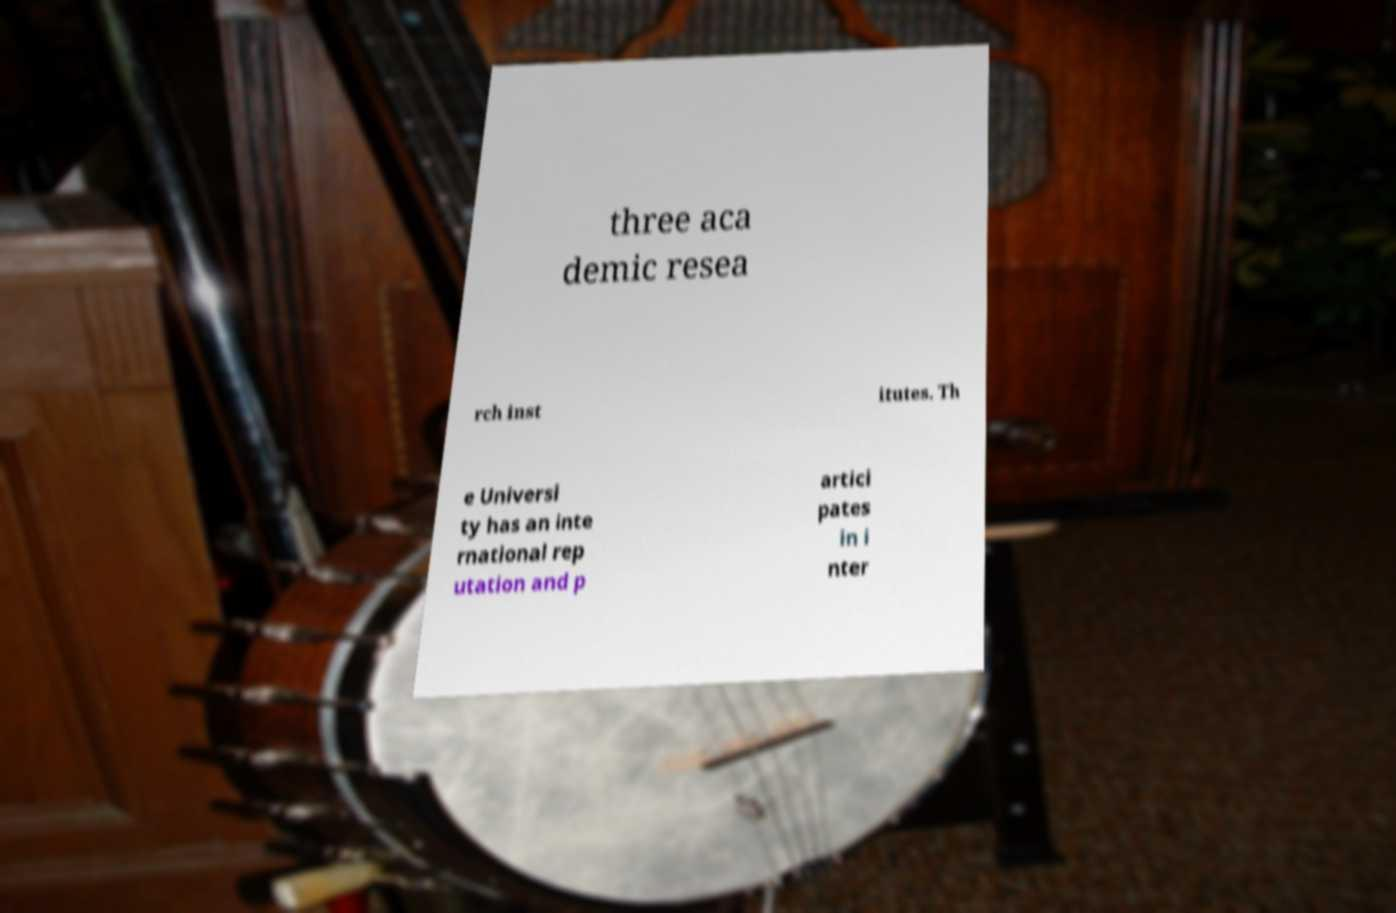There's text embedded in this image that I need extracted. Can you transcribe it verbatim? three aca demic resea rch inst itutes. Th e Universi ty has an inte rnational rep utation and p artici pates in i nter 